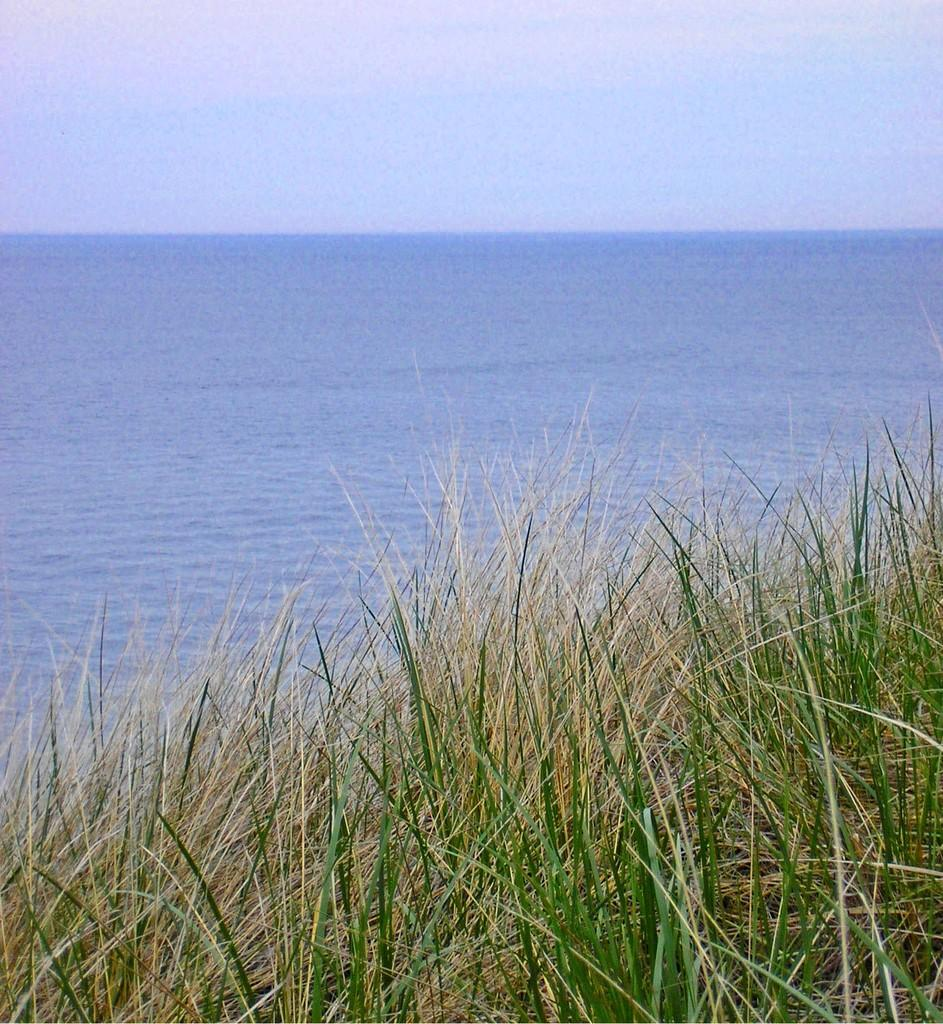What is the location of the image in relation to the city? The image is taken from the outside of the city. What type of vegetation can be seen in the image? There are plants and grass in the image. What body of water is visible in the background of the image? There is a lake with water in the background of the image. What part of the natural environment is visible in the image? The sky is visible at the top of the image. What government policy is responsible for the destruction seen in the image? There is no destruction visible in the image, and therefore no government policy can be associated with it. 